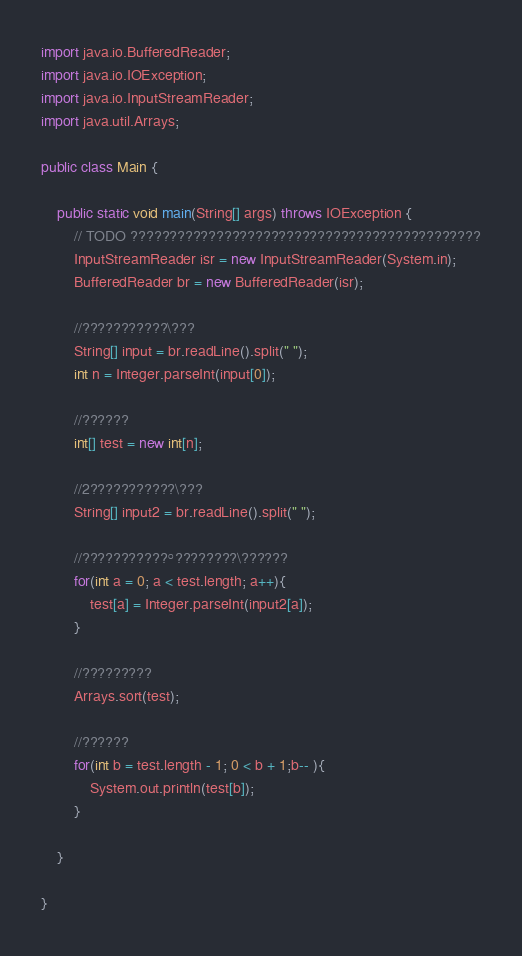<code> <loc_0><loc_0><loc_500><loc_500><_Java_>import java.io.BufferedReader;
import java.io.IOException;
import java.io.InputStreamReader;
import java.util.Arrays;

public class Main {

	public static void main(String[] args) throws IOException {
		// TODO ?????????????????????????????????????????????
		InputStreamReader isr = new InputStreamReader(System.in);
        BufferedReader br = new BufferedReader(isr);

        //???????????\???
        String[] input = br.readLine().split(" ");
        int n = Integer.parseInt(input[0]);

        //??????
        int[] test = new int[n];

        //2???????????\???
        String[] input2 = br.readLine().split(" ");

        //???????????°????????\??????
        for(int a = 0; a < test.length; a++){
        	test[a] = Integer.parseInt(input2[a]);
        }

        //?????????
        Arrays.sort(test);

        //??????
        for(int b = test.length - 1; 0 < b + 1;b-- ){
        	System.out.println(test[b]);
        }

	}

}</code> 